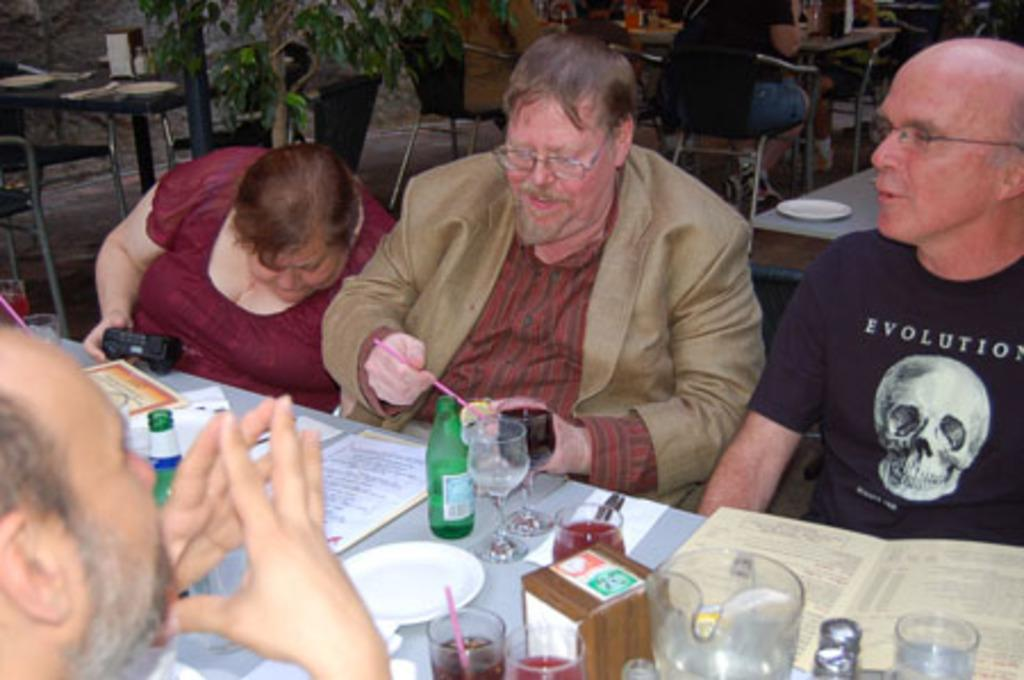How many people are present in the image? There are four people in the image: three men and one woman. What are the people doing in the image? The people are sitting at a table and talking among themselves. What type of cloud can be seen in the image? There is no cloud present in the image; it features people sitting at a table and talking. What kind of grain is being used to make the table in the image? There is no information about the table's material in the image, so it cannot be determined if grain is used. 